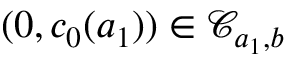<formula> <loc_0><loc_0><loc_500><loc_500>( 0 , c _ { 0 } ( a _ { 1 } ) ) \in \mathcal { C } _ { a _ { 1 } , b }</formula> 